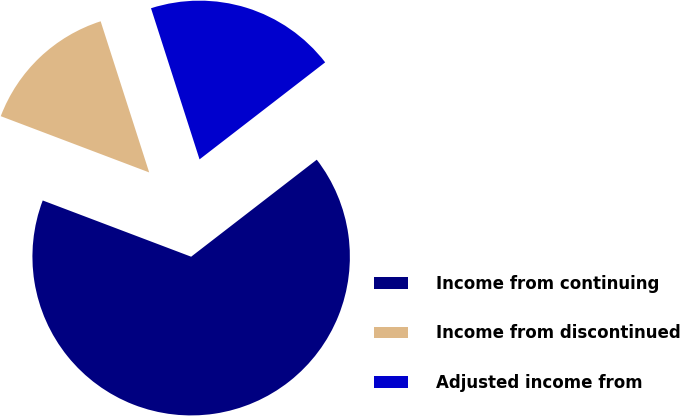<chart> <loc_0><loc_0><loc_500><loc_500><pie_chart><fcel>Income from continuing<fcel>Income from discontinued<fcel>Adjusted income from<nl><fcel>66.23%<fcel>14.29%<fcel>19.48%<nl></chart> 